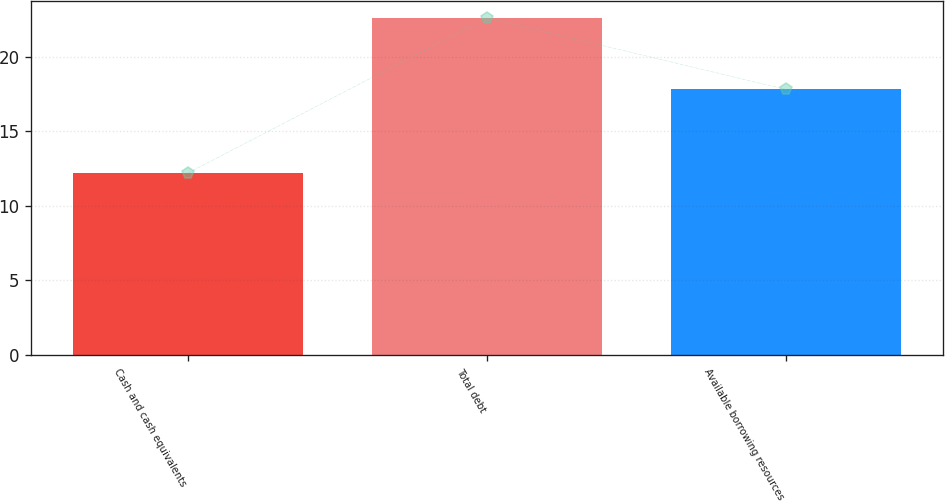<chart> <loc_0><loc_0><loc_500><loc_500><bar_chart><fcel>Cash and cash equivalents<fcel>Total debt<fcel>Available borrowing resources<nl><fcel>12.2<fcel>22.6<fcel>17.8<nl></chart> 